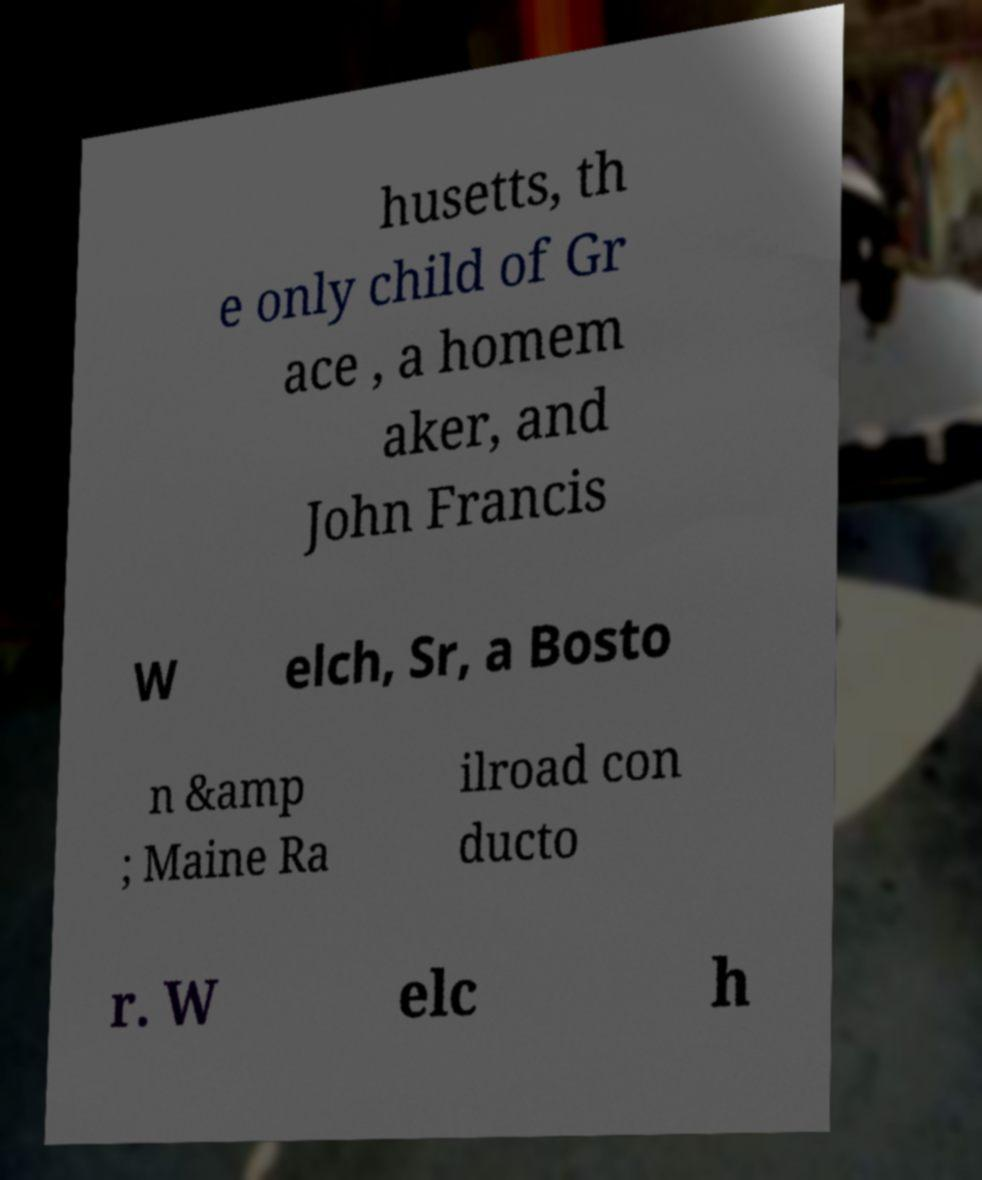There's text embedded in this image that I need extracted. Can you transcribe it verbatim? husetts, th e only child of Gr ace , a homem aker, and John Francis W elch, Sr, a Bosto n &amp ; Maine Ra ilroad con ducto r. W elc h 